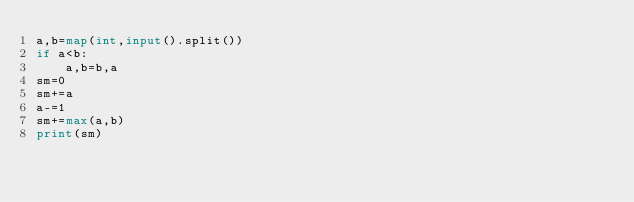<code> <loc_0><loc_0><loc_500><loc_500><_Python_>a,b=map(int,input().split())
if a<b:
    a,b=b,a 
sm=0
sm+=a 
a-=1 
sm+=max(a,b)
print(sm)</code> 